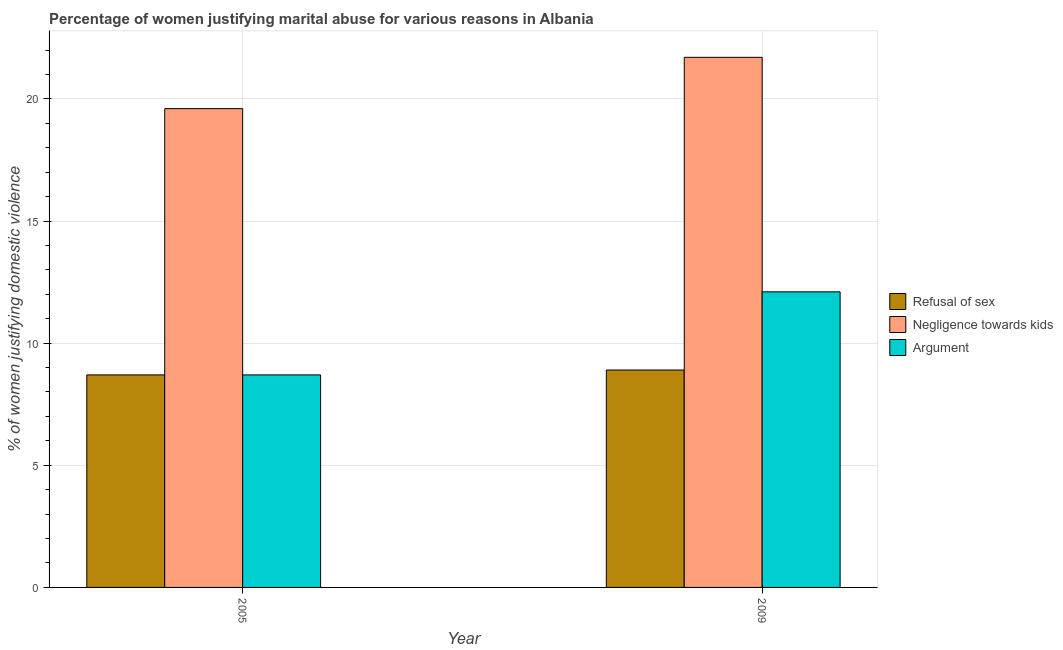How many groups of bars are there?
Your answer should be compact. 2. What is the percentage of women justifying domestic violence due to arguments in 2005?
Offer a terse response. 8.7. Across all years, what is the maximum percentage of women justifying domestic violence due to negligence towards kids?
Offer a terse response. 21.7. Across all years, what is the minimum percentage of women justifying domestic violence due to negligence towards kids?
Make the answer very short. 19.6. In which year was the percentage of women justifying domestic violence due to negligence towards kids maximum?
Offer a terse response. 2009. In which year was the percentage of women justifying domestic violence due to refusal of sex minimum?
Ensure brevity in your answer.  2005. What is the total percentage of women justifying domestic violence due to negligence towards kids in the graph?
Keep it short and to the point. 41.3. What is the difference between the percentage of women justifying domestic violence due to arguments in 2005 and that in 2009?
Make the answer very short. -3.4. What is the difference between the percentage of women justifying domestic violence due to negligence towards kids in 2005 and the percentage of women justifying domestic violence due to arguments in 2009?
Offer a terse response. -2.1. What is the ratio of the percentage of women justifying domestic violence due to arguments in 2005 to that in 2009?
Your answer should be compact. 0.72. In how many years, is the percentage of women justifying domestic violence due to arguments greater than the average percentage of women justifying domestic violence due to arguments taken over all years?
Your answer should be compact. 1. What does the 3rd bar from the left in 2005 represents?
Your answer should be very brief. Argument. What does the 3rd bar from the right in 2005 represents?
Offer a terse response. Refusal of sex. How many bars are there?
Give a very brief answer. 6. How many years are there in the graph?
Offer a very short reply. 2. What is the difference between two consecutive major ticks on the Y-axis?
Provide a short and direct response. 5. Are the values on the major ticks of Y-axis written in scientific E-notation?
Your answer should be very brief. No. Does the graph contain grids?
Make the answer very short. Yes. What is the title of the graph?
Your response must be concise. Percentage of women justifying marital abuse for various reasons in Albania. Does "Financial account" appear as one of the legend labels in the graph?
Ensure brevity in your answer.  No. What is the label or title of the X-axis?
Your answer should be compact. Year. What is the label or title of the Y-axis?
Your answer should be compact. % of women justifying domestic violence. What is the % of women justifying domestic violence in Refusal of sex in 2005?
Provide a succinct answer. 8.7. What is the % of women justifying domestic violence of Negligence towards kids in 2005?
Offer a terse response. 19.6. What is the % of women justifying domestic violence in Refusal of sex in 2009?
Provide a succinct answer. 8.9. What is the % of women justifying domestic violence of Negligence towards kids in 2009?
Keep it short and to the point. 21.7. Across all years, what is the maximum % of women justifying domestic violence in Refusal of sex?
Ensure brevity in your answer.  8.9. Across all years, what is the maximum % of women justifying domestic violence of Negligence towards kids?
Your response must be concise. 21.7. Across all years, what is the maximum % of women justifying domestic violence in Argument?
Keep it short and to the point. 12.1. Across all years, what is the minimum % of women justifying domestic violence in Negligence towards kids?
Offer a very short reply. 19.6. What is the total % of women justifying domestic violence of Refusal of sex in the graph?
Ensure brevity in your answer.  17.6. What is the total % of women justifying domestic violence in Negligence towards kids in the graph?
Ensure brevity in your answer.  41.3. What is the total % of women justifying domestic violence of Argument in the graph?
Make the answer very short. 20.8. What is the difference between the % of women justifying domestic violence of Refusal of sex in 2005 and that in 2009?
Provide a succinct answer. -0.2. What is the difference between the % of women justifying domestic violence in Negligence towards kids in 2005 and that in 2009?
Your answer should be very brief. -2.1. What is the difference between the % of women justifying domestic violence in Refusal of sex in 2005 and the % of women justifying domestic violence in Negligence towards kids in 2009?
Your answer should be very brief. -13. What is the difference between the % of women justifying domestic violence in Refusal of sex in 2005 and the % of women justifying domestic violence in Argument in 2009?
Your answer should be compact. -3.4. What is the difference between the % of women justifying domestic violence of Negligence towards kids in 2005 and the % of women justifying domestic violence of Argument in 2009?
Make the answer very short. 7.5. What is the average % of women justifying domestic violence of Negligence towards kids per year?
Ensure brevity in your answer.  20.65. In the year 2005, what is the difference between the % of women justifying domestic violence of Refusal of sex and % of women justifying domestic violence of Argument?
Your answer should be compact. 0. In the year 2005, what is the difference between the % of women justifying domestic violence in Negligence towards kids and % of women justifying domestic violence in Argument?
Provide a succinct answer. 10.9. In the year 2009, what is the difference between the % of women justifying domestic violence in Refusal of sex and % of women justifying domestic violence in Negligence towards kids?
Your response must be concise. -12.8. What is the ratio of the % of women justifying domestic violence in Refusal of sex in 2005 to that in 2009?
Your answer should be compact. 0.98. What is the ratio of the % of women justifying domestic violence of Negligence towards kids in 2005 to that in 2009?
Offer a very short reply. 0.9. What is the ratio of the % of women justifying domestic violence of Argument in 2005 to that in 2009?
Your answer should be compact. 0.72. What is the difference between the highest and the second highest % of women justifying domestic violence of Refusal of sex?
Offer a very short reply. 0.2. What is the difference between the highest and the second highest % of women justifying domestic violence in Argument?
Ensure brevity in your answer.  3.4. What is the difference between the highest and the lowest % of women justifying domestic violence in Refusal of sex?
Offer a very short reply. 0.2. What is the difference between the highest and the lowest % of women justifying domestic violence of Argument?
Offer a very short reply. 3.4. 